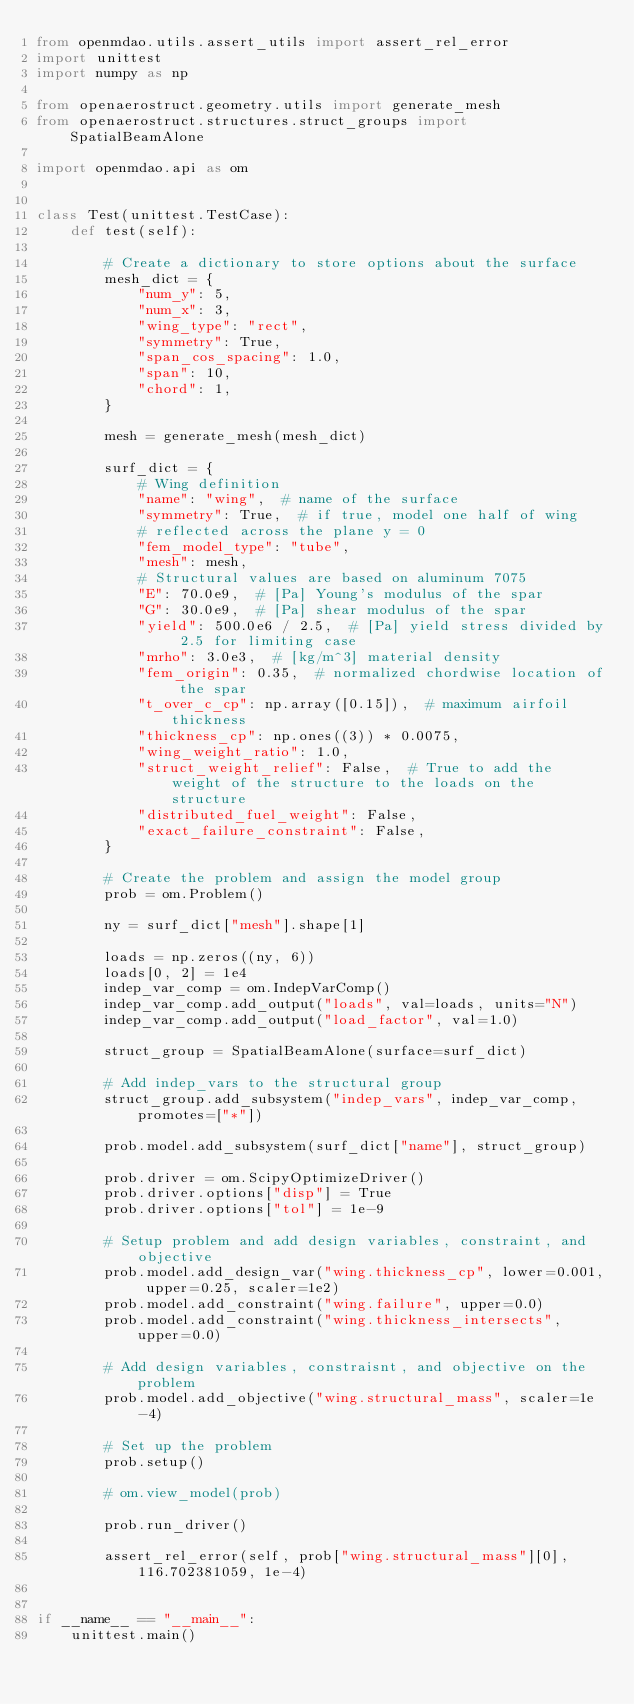<code> <loc_0><loc_0><loc_500><loc_500><_Python_>from openmdao.utils.assert_utils import assert_rel_error
import unittest
import numpy as np

from openaerostruct.geometry.utils import generate_mesh
from openaerostruct.structures.struct_groups import SpatialBeamAlone

import openmdao.api as om


class Test(unittest.TestCase):
    def test(self):

        # Create a dictionary to store options about the surface
        mesh_dict = {
            "num_y": 5,
            "num_x": 3,
            "wing_type": "rect",
            "symmetry": True,
            "span_cos_spacing": 1.0,
            "span": 10,
            "chord": 1,
        }

        mesh = generate_mesh(mesh_dict)

        surf_dict = {
            # Wing definition
            "name": "wing",  # name of the surface
            "symmetry": True,  # if true, model one half of wing
            # reflected across the plane y = 0
            "fem_model_type": "tube",
            "mesh": mesh,
            # Structural values are based on aluminum 7075
            "E": 70.0e9,  # [Pa] Young's modulus of the spar
            "G": 30.0e9,  # [Pa] shear modulus of the spar
            "yield": 500.0e6 / 2.5,  # [Pa] yield stress divided by 2.5 for limiting case
            "mrho": 3.0e3,  # [kg/m^3] material density
            "fem_origin": 0.35,  # normalized chordwise location of the spar
            "t_over_c_cp": np.array([0.15]),  # maximum airfoil thickness
            "thickness_cp": np.ones((3)) * 0.0075,
            "wing_weight_ratio": 1.0,
            "struct_weight_relief": False,  # True to add the weight of the structure to the loads on the structure
            "distributed_fuel_weight": False,
            "exact_failure_constraint": False,
        }

        # Create the problem and assign the model group
        prob = om.Problem()

        ny = surf_dict["mesh"].shape[1]

        loads = np.zeros((ny, 6))
        loads[0, 2] = 1e4
        indep_var_comp = om.IndepVarComp()
        indep_var_comp.add_output("loads", val=loads, units="N")
        indep_var_comp.add_output("load_factor", val=1.0)

        struct_group = SpatialBeamAlone(surface=surf_dict)

        # Add indep_vars to the structural group
        struct_group.add_subsystem("indep_vars", indep_var_comp, promotes=["*"])

        prob.model.add_subsystem(surf_dict["name"], struct_group)

        prob.driver = om.ScipyOptimizeDriver()
        prob.driver.options["disp"] = True
        prob.driver.options["tol"] = 1e-9

        # Setup problem and add design variables, constraint, and objective
        prob.model.add_design_var("wing.thickness_cp", lower=0.001, upper=0.25, scaler=1e2)
        prob.model.add_constraint("wing.failure", upper=0.0)
        prob.model.add_constraint("wing.thickness_intersects", upper=0.0)

        # Add design variables, constraisnt, and objective on the problem
        prob.model.add_objective("wing.structural_mass", scaler=1e-4)

        # Set up the problem
        prob.setup()

        # om.view_model(prob)

        prob.run_driver()

        assert_rel_error(self, prob["wing.structural_mass"][0], 116.702381059, 1e-4)


if __name__ == "__main__":
    unittest.main()
</code> 